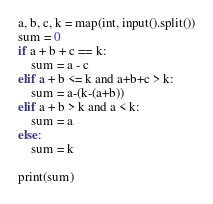Convert code to text. <code><loc_0><loc_0><loc_500><loc_500><_Python_>a, b, c, k = map(int, input().split())
sum = 0
if a + b + c == k:
    sum = a - c
elif a + b <= k and a+b+c > k:
    sum = a-(k-(a+b))
elif a + b > k and a < k:
    sum = a
else:
    sum = k

print(sum)
</code> 